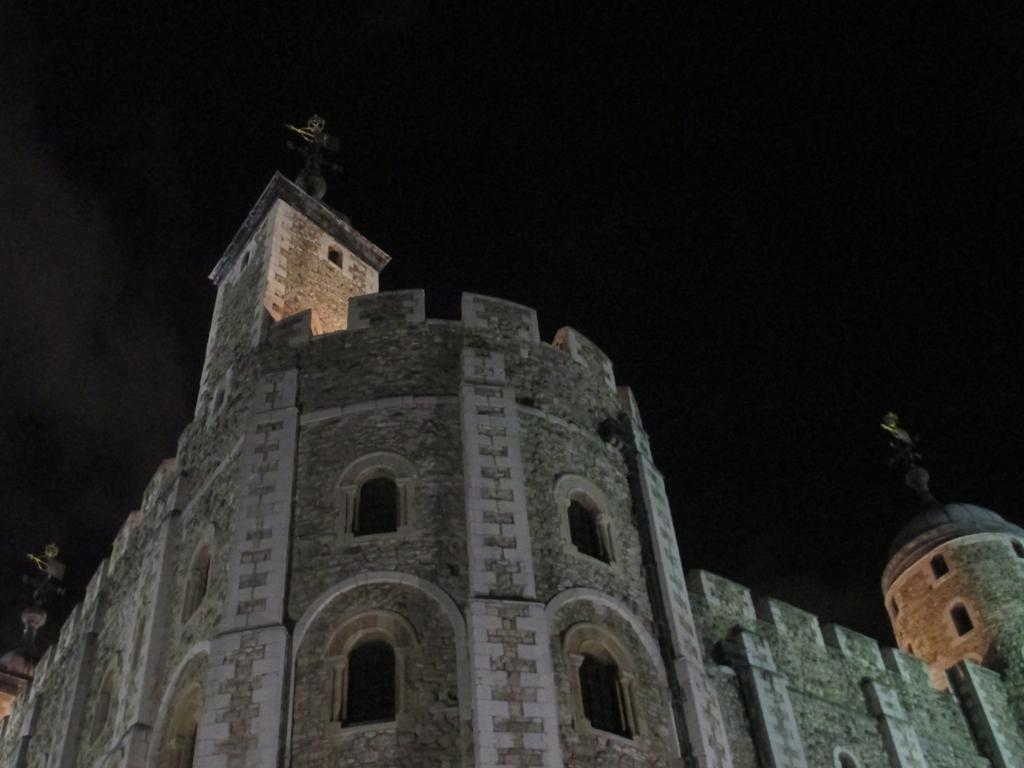How would you summarize this image in a sentence or two? In this image I can see a huge fort and few windows of the fort. In the background I can see the dark sky. 